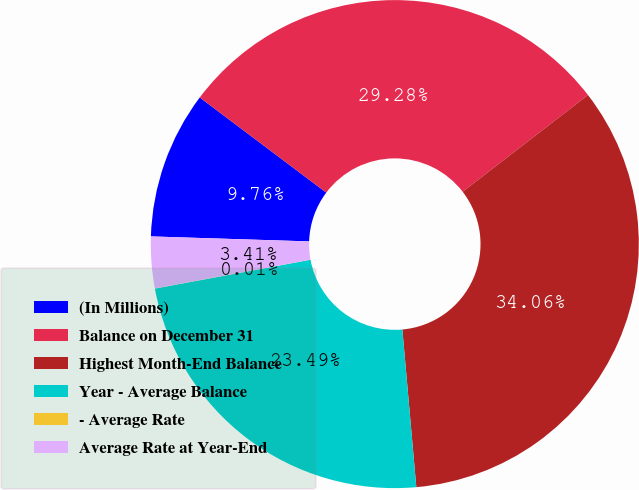<chart> <loc_0><loc_0><loc_500><loc_500><pie_chart><fcel>(In Millions)<fcel>Balance on December 31<fcel>Highest Month-End Balance<fcel>Year - Average Balance<fcel>- Average Rate<fcel>Average Rate at Year-End<nl><fcel>9.76%<fcel>29.28%<fcel>34.06%<fcel>23.49%<fcel>0.01%<fcel>3.41%<nl></chart> 